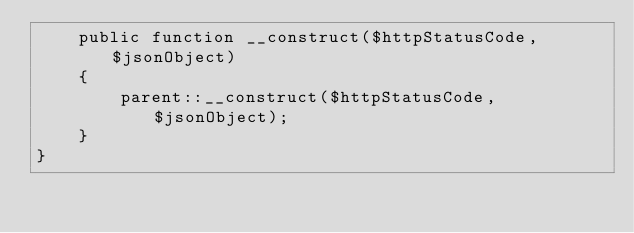<code> <loc_0><loc_0><loc_500><loc_500><_PHP_>    public function __construct($httpStatusCode, $jsonObject)
    {
        parent::__construct($httpStatusCode, $jsonObject);
    }
}
</code> 